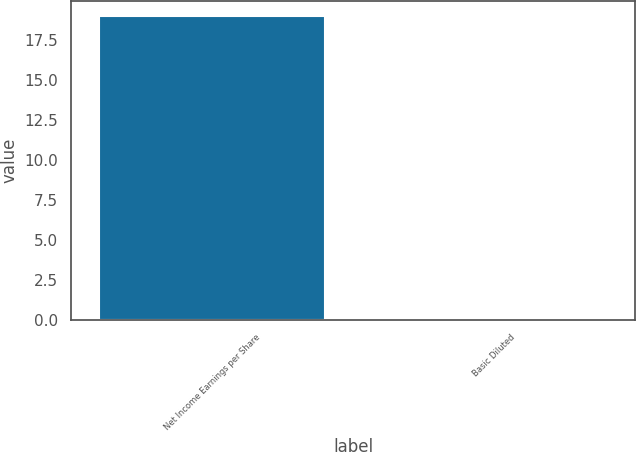Convert chart to OTSL. <chart><loc_0><loc_0><loc_500><loc_500><bar_chart><fcel>Net Income Earnings per Share<fcel>Basic Diluted<nl><fcel>19<fcel>0.09<nl></chart> 